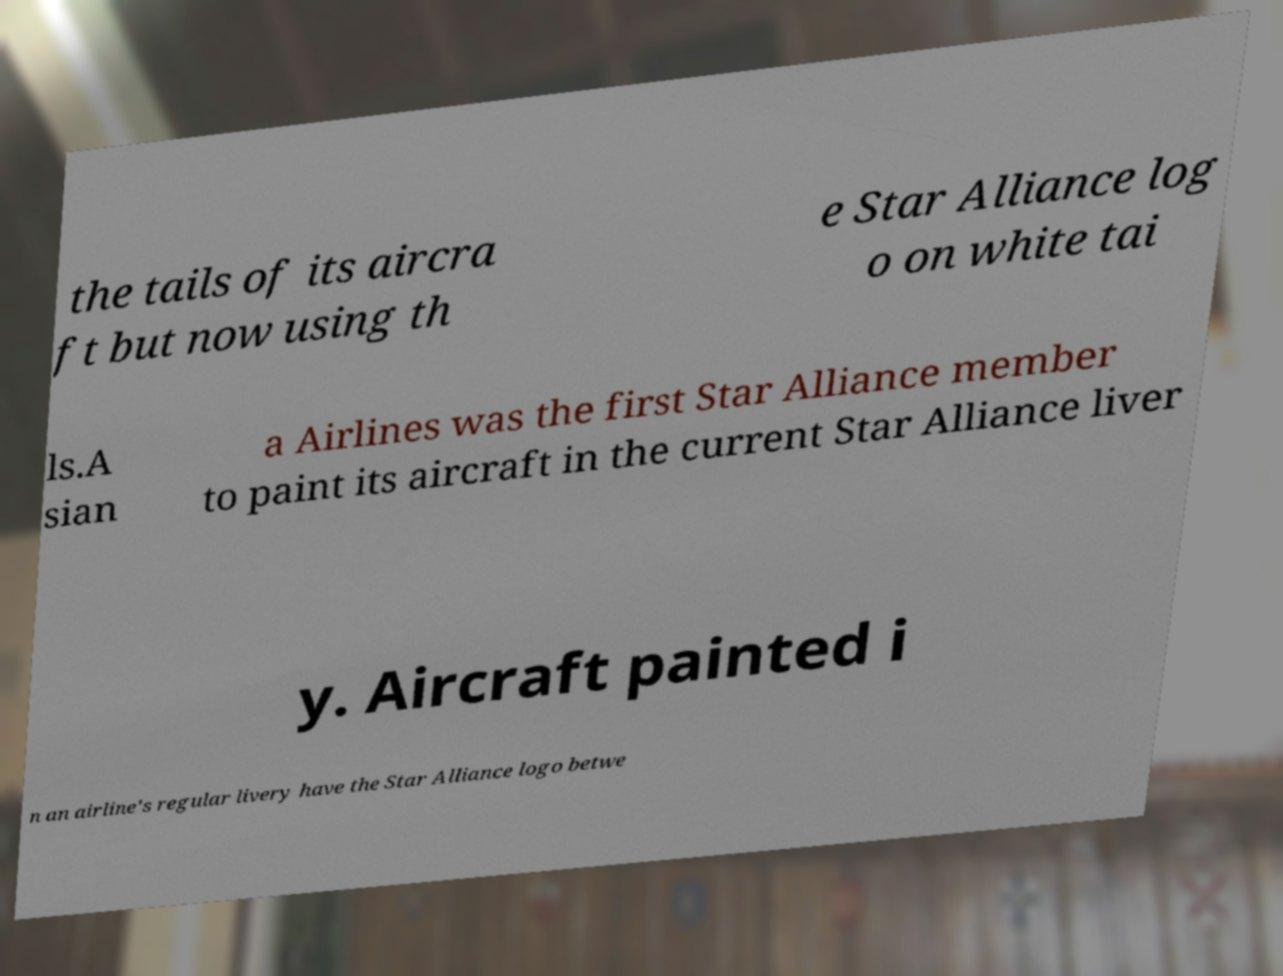There's text embedded in this image that I need extracted. Can you transcribe it verbatim? the tails of its aircra ft but now using th e Star Alliance log o on white tai ls.A sian a Airlines was the first Star Alliance member to paint its aircraft in the current Star Alliance liver y. Aircraft painted i n an airline's regular livery have the Star Alliance logo betwe 